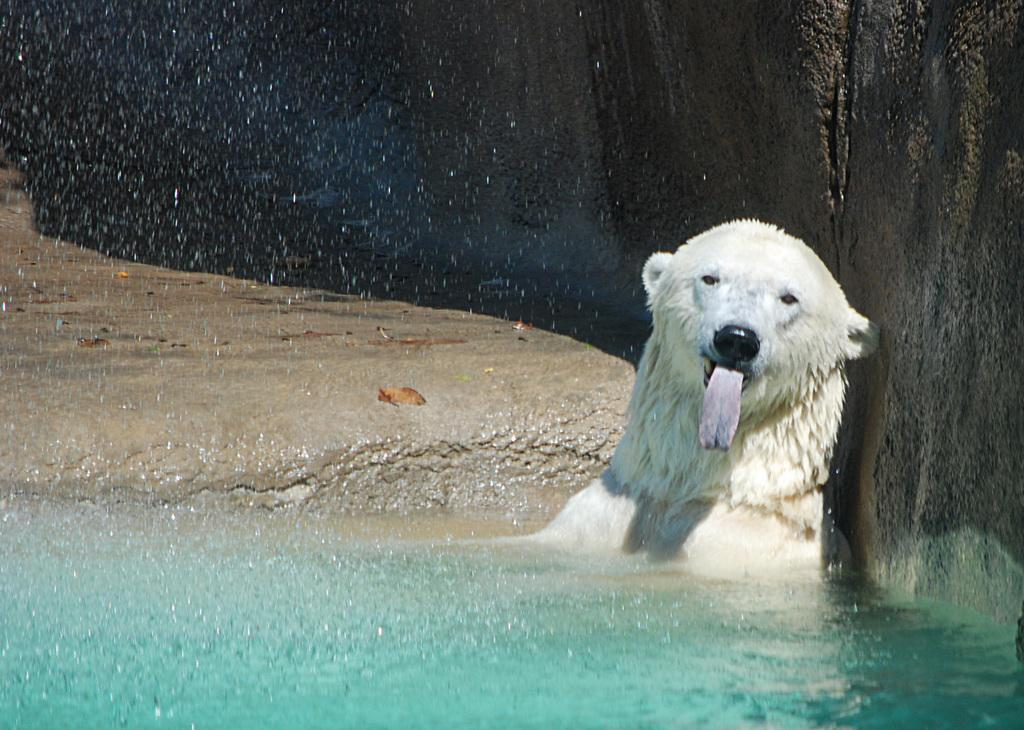What type of animal is in the image? There is a white bear in the image. Where is the bear located? The bear is in the water. What other objects can be seen in the image? There are big stones in the image. How many nails can be seen in the image? There are no nails present in the image. What type of rest is the bear taking in the image? The image does not show the bear resting; it is in the water. 